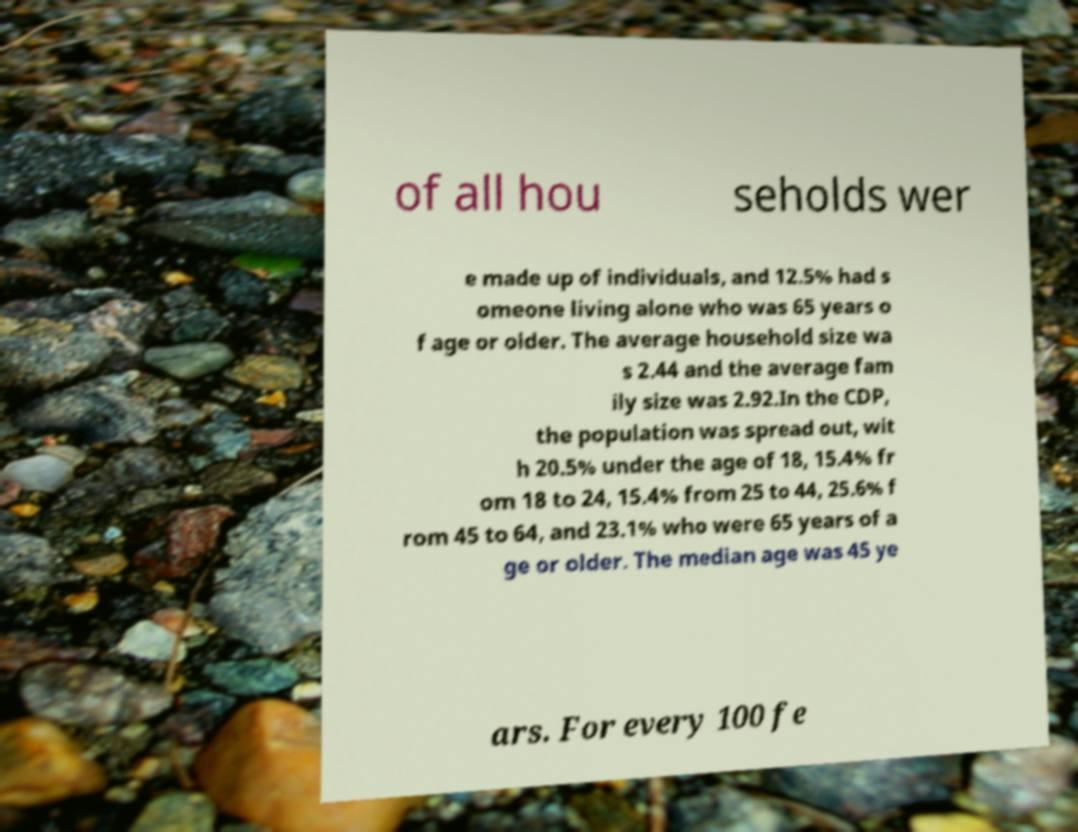I need the written content from this picture converted into text. Can you do that? of all hou seholds wer e made up of individuals, and 12.5% had s omeone living alone who was 65 years o f age or older. The average household size wa s 2.44 and the average fam ily size was 2.92.In the CDP, the population was spread out, wit h 20.5% under the age of 18, 15.4% fr om 18 to 24, 15.4% from 25 to 44, 25.6% f rom 45 to 64, and 23.1% who were 65 years of a ge or older. The median age was 45 ye ars. For every 100 fe 